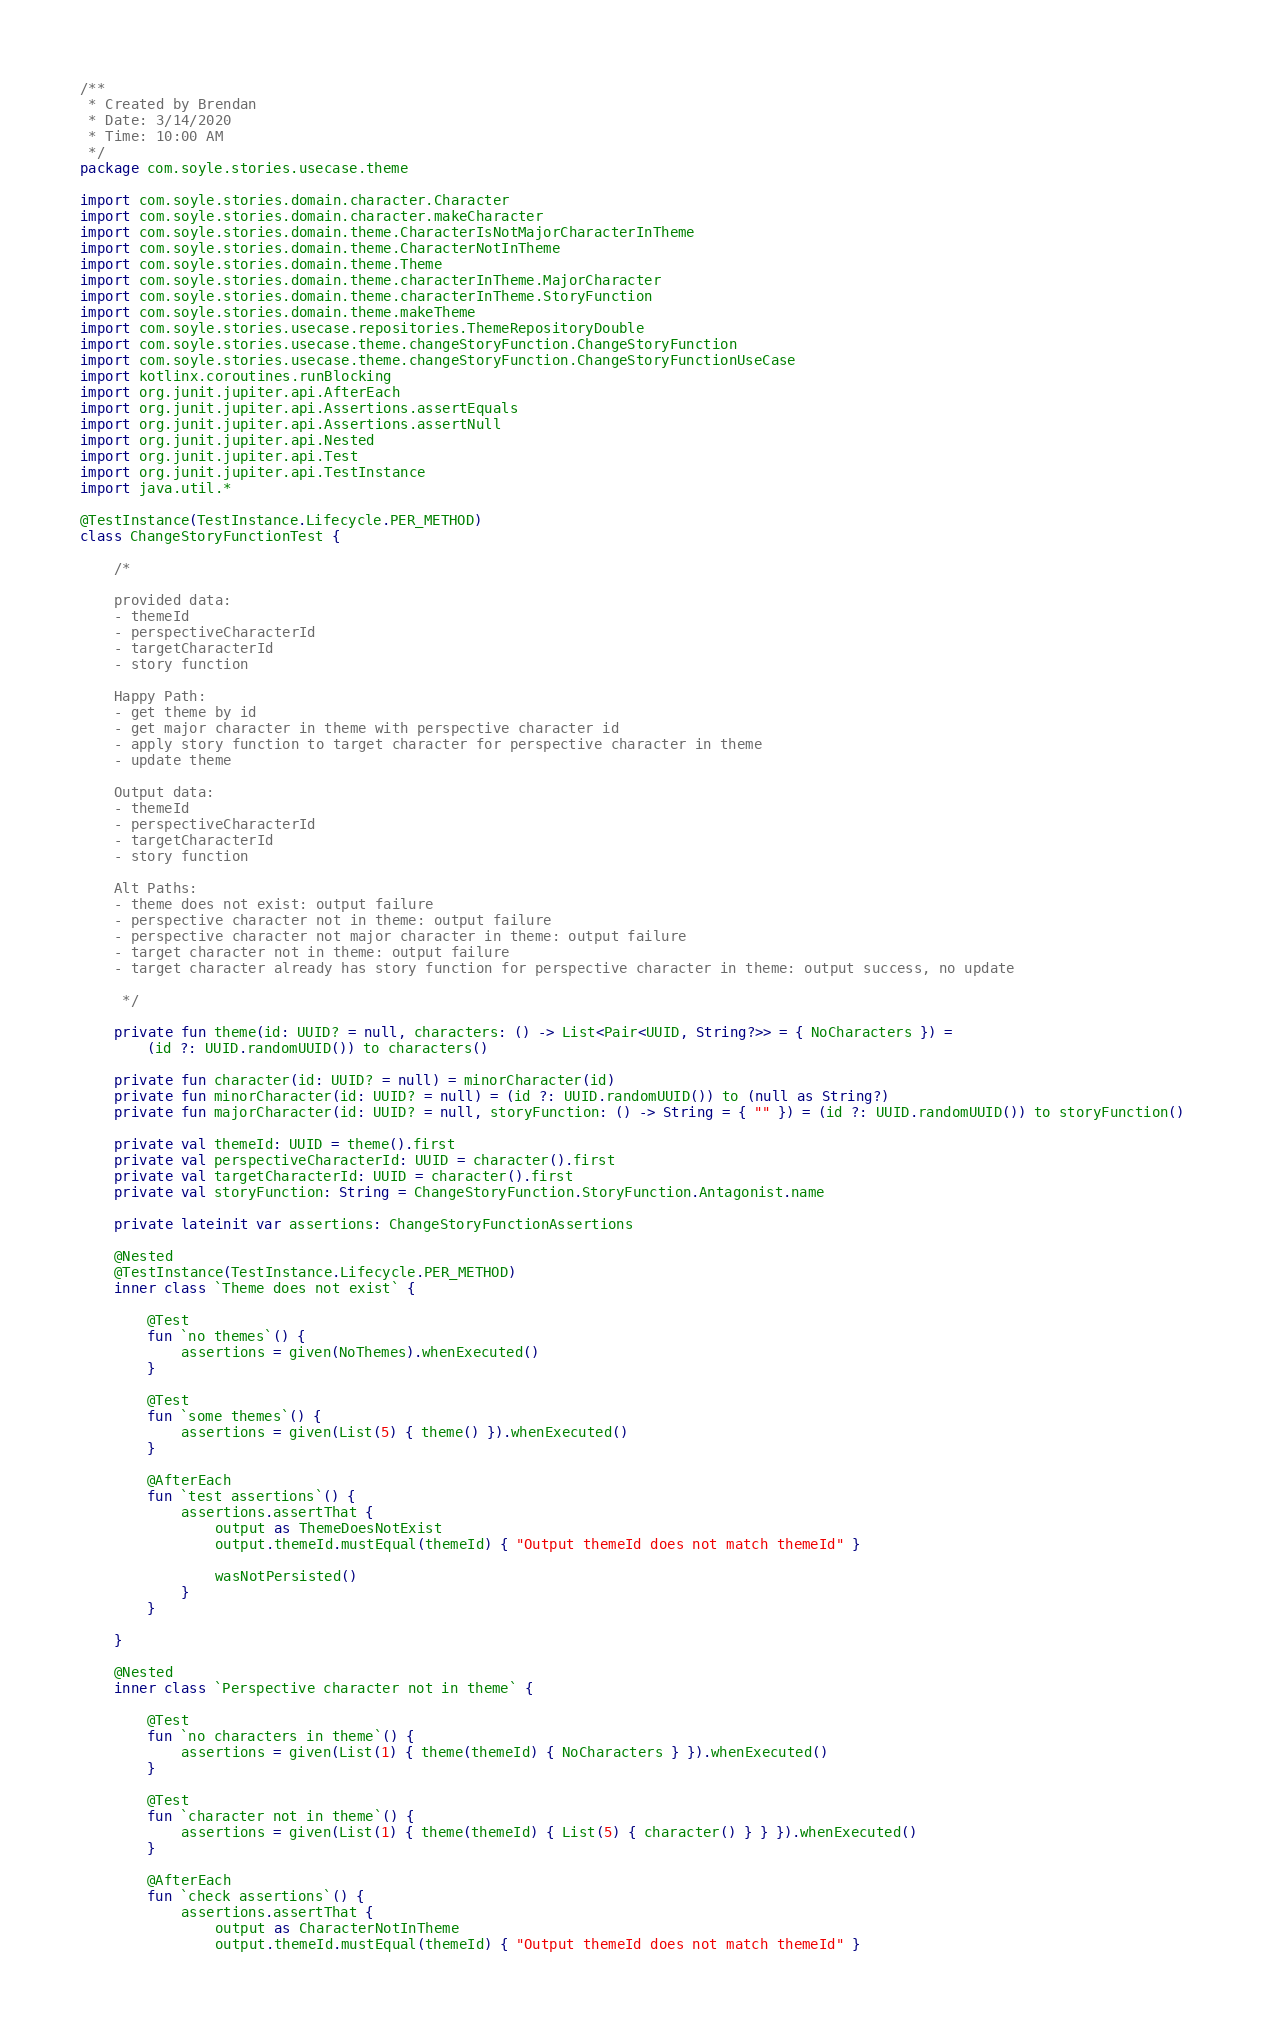<code> <loc_0><loc_0><loc_500><loc_500><_Kotlin_>/**
 * Created by Brendan
 * Date: 3/14/2020
 * Time: 10:00 AM
 */
package com.soyle.stories.usecase.theme

import com.soyle.stories.domain.character.Character
import com.soyle.stories.domain.character.makeCharacter
import com.soyle.stories.domain.theme.CharacterIsNotMajorCharacterInTheme
import com.soyle.stories.domain.theme.CharacterNotInTheme
import com.soyle.stories.domain.theme.Theme
import com.soyle.stories.domain.theme.characterInTheme.MajorCharacter
import com.soyle.stories.domain.theme.characterInTheme.StoryFunction
import com.soyle.stories.domain.theme.makeTheme
import com.soyle.stories.usecase.repositories.ThemeRepositoryDouble
import com.soyle.stories.usecase.theme.changeStoryFunction.ChangeStoryFunction
import com.soyle.stories.usecase.theme.changeStoryFunction.ChangeStoryFunctionUseCase
import kotlinx.coroutines.runBlocking
import org.junit.jupiter.api.AfterEach
import org.junit.jupiter.api.Assertions.assertEquals
import org.junit.jupiter.api.Assertions.assertNull
import org.junit.jupiter.api.Nested
import org.junit.jupiter.api.Test
import org.junit.jupiter.api.TestInstance
import java.util.*

@TestInstance(TestInstance.Lifecycle.PER_METHOD)
class ChangeStoryFunctionTest {

    /*

    provided data:
    - themeId
    - perspectiveCharacterId
    - targetCharacterId
    - story function

    Happy Path:
    - get theme by id
    - get major character in theme with perspective character id
    - apply story function to target character for perspective character in theme
    - update theme

    Output data:
    - themeId
    - perspectiveCharacterId
    - targetCharacterId
    - story function

    Alt Paths:
    - theme does not exist: output failure
    - perspective character not in theme: output failure
    - perspective character not major character in theme: output failure
    - target character not in theme: output failure
    - target character already has story function for perspective character in theme: output success, no update

     */

    private fun theme(id: UUID? = null, characters: () -> List<Pair<UUID, String?>> = { NoCharacters }) =
        (id ?: UUID.randomUUID()) to characters()

    private fun character(id: UUID? = null) = minorCharacter(id)
    private fun minorCharacter(id: UUID? = null) = (id ?: UUID.randomUUID()) to (null as String?)
    private fun majorCharacter(id: UUID? = null, storyFunction: () -> String = { "" }) = (id ?: UUID.randomUUID()) to storyFunction()

    private val themeId: UUID = theme().first
    private val perspectiveCharacterId: UUID = character().first
    private val targetCharacterId: UUID = character().first
    private val storyFunction: String = ChangeStoryFunction.StoryFunction.Antagonist.name

    private lateinit var assertions: ChangeStoryFunctionAssertions

    @Nested
    @TestInstance(TestInstance.Lifecycle.PER_METHOD)
    inner class `Theme does not exist` {

        @Test
        fun `no themes`() {
            assertions = given(NoThemes).whenExecuted()
        }

        @Test
        fun `some themes`() {
            assertions = given(List(5) { theme() }).whenExecuted()
        }

        @AfterEach
        fun `test assertions`() {
            assertions.assertThat {
                output as ThemeDoesNotExist
                output.themeId.mustEqual(themeId) { "Output themeId does not match themeId" }

                wasNotPersisted()
            }
        }

    }

    @Nested
    inner class `Perspective character not in theme` {

        @Test
        fun `no characters in theme`() {
            assertions = given(List(1) { theme(themeId) { NoCharacters } }).whenExecuted()
        }

        @Test
        fun `character not in theme`() {
            assertions = given(List(1) { theme(themeId) { List(5) { character() } } }).whenExecuted()
        }

        @AfterEach
        fun `check assertions`() {
            assertions.assertThat {
                output as CharacterNotInTheme
                output.themeId.mustEqual(themeId) { "Output themeId does not match themeId" }</code> 